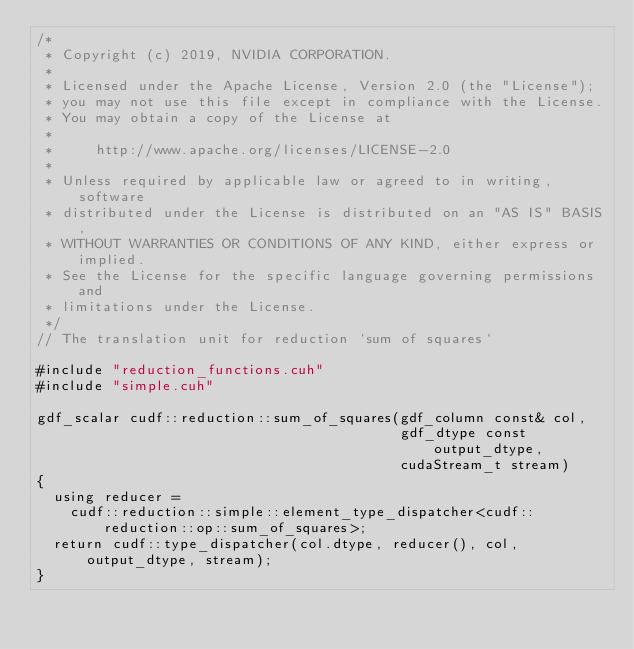Convert code to text. <code><loc_0><loc_0><loc_500><loc_500><_Cuda_>/*
 * Copyright (c) 2019, NVIDIA CORPORATION.
 *
 * Licensed under the Apache License, Version 2.0 (the "License");
 * you may not use this file except in compliance with the License.
 * You may obtain a copy of the License at
 *
 *     http://www.apache.org/licenses/LICENSE-2.0
 *
 * Unless required by applicable law or agreed to in writing, software
 * distributed under the License is distributed on an "AS IS" BASIS,
 * WITHOUT WARRANTIES OR CONDITIONS OF ANY KIND, either express or implied.
 * See the License for the specific language governing permissions and
 * limitations under the License.
 */
// The translation unit for reduction `sum of squares`

#include "reduction_functions.cuh"
#include "simple.cuh"

gdf_scalar cudf::reduction::sum_of_squares(gdf_column const& col,
                                           gdf_dtype const output_dtype,
                                           cudaStream_t stream)
{
  using reducer =
    cudf::reduction::simple::element_type_dispatcher<cudf::reduction::op::sum_of_squares>;
  return cudf::type_dispatcher(col.dtype, reducer(), col, output_dtype, stream);
}
</code> 